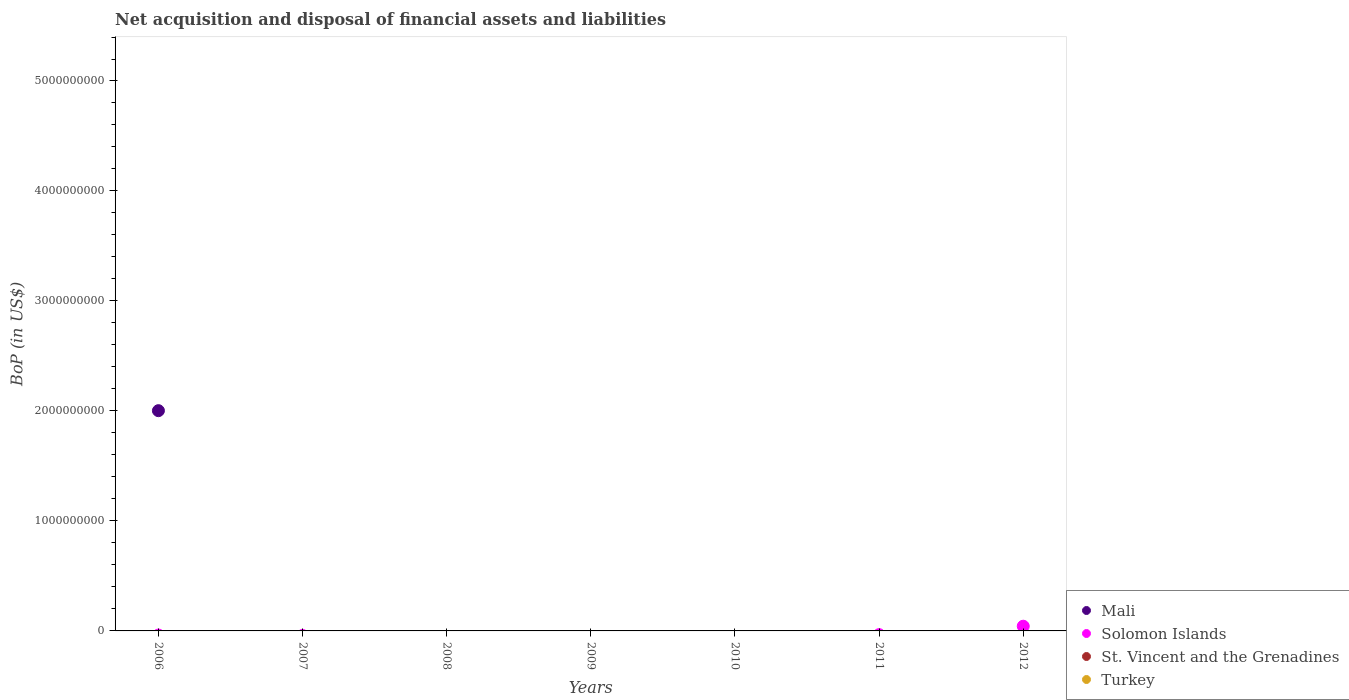Is the number of dotlines equal to the number of legend labels?
Offer a very short reply. No. What is the Balance of Payments in St. Vincent and the Grenadines in 2008?
Your answer should be compact. 0. Across all years, what is the maximum Balance of Payments in Mali?
Provide a short and direct response. 2.00e+09. In which year was the Balance of Payments in Mali maximum?
Ensure brevity in your answer.  2006. What is the total Balance of Payments in St. Vincent and the Grenadines in the graph?
Your answer should be very brief. 0. What is the average Balance of Payments in Mali per year?
Provide a succinct answer. 2.86e+08. In how many years, is the Balance of Payments in Solomon Islands greater than 1000000000 US$?
Your response must be concise. 0. What is the difference between the highest and the lowest Balance of Payments in Mali?
Your response must be concise. 2.00e+09. Does the Balance of Payments in Mali monotonically increase over the years?
Keep it short and to the point. No. Is the Balance of Payments in St. Vincent and the Grenadines strictly less than the Balance of Payments in Turkey over the years?
Give a very brief answer. No. How many dotlines are there?
Make the answer very short. 2. What is the difference between two consecutive major ticks on the Y-axis?
Keep it short and to the point. 1.00e+09. Does the graph contain any zero values?
Make the answer very short. Yes. How many legend labels are there?
Give a very brief answer. 4. What is the title of the graph?
Provide a short and direct response. Net acquisition and disposal of financial assets and liabilities. What is the label or title of the Y-axis?
Keep it short and to the point. BoP (in US$). What is the BoP (in US$) in Mali in 2006?
Ensure brevity in your answer.  2.00e+09. What is the BoP (in US$) in St. Vincent and the Grenadines in 2006?
Give a very brief answer. 0. What is the BoP (in US$) in Turkey in 2006?
Give a very brief answer. 0. What is the BoP (in US$) in Mali in 2007?
Keep it short and to the point. 0. What is the BoP (in US$) in Solomon Islands in 2007?
Your response must be concise. 0. What is the BoP (in US$) of St. Vincent and the Grenadines in 2007?
Ensure brevity in your answer.  0. What is the BoP (in US$) of Turkey in 2007?
Keep it short and to the point. 0. What is the BoP (in US$) in Mali in 2008?
Keep it short and to the point. 0. What is the BoP (in US$) of Solomon Islands in 2008?
Provide a succinct answer. 0. What is the BoP (in US$) of St. Vincent and the Grenadines in 2008?
Your answer should be compact. 0. What is the BoP (in US$) of Turkey in 2008?
Make the answer very short. 0. What is the BoP (in US$) of Mali in 2009?
Your response must be concise. 0. What is the BoP (in US$) in Solomon Islands in 2009?
Give a very brief answer. 0. What is the BoP (in US$) in St. Vincent and the Grenadines in 2009?
Offer a terse response. 0. What is the BoP (in US$) of Solomon Islands in 2010?
Give a very brief answer. 0. What is the BoP (in US$) in St. Vincent and the Grenadines in 2010?
Keep it short and to the point. 0. What is the BoP (in US$) in Turkey in 2010?
Give a very brief answer. 0. What is the BoP (in US$) in St. Vincent and the Grenadines in 2011?
Make the answer very short. 0. What is the BoP (in US$) in Turkey in 2011?
Offer a terse response. 0. What is the BoP (in US$) in Mali in 2012?
Provide a short and direct response. 0. What is the BoP (in US$) of Solomon Islands in 2012?
Your answer should be very brief. 4.28e+07. What is the BoP (in US$) of Turkey in 2012?
Your response must be concise. 0. Across all years, what is the maximum BoP (in US$) of Mali?
Offer a very short reply. 2.00e+09. Across all years, what is the maximum BoP (in US$) of Solomon Islands?
Offer a very short reply. 4.28e+07. What is the total BoP (in US$) of Mali in the graph?
Your answer should be very brief. 2.00e+09. What is the total BoP (in US$) of Solomon Islands in the graph?
Make the answer very short. 4.28e+07. What is the total BoP (in US$) of St. Vincent and the Grenadines in the graph?
Ensure brevity in your answer.  0. What is the total BoP (in US$) in Turkey in the graph?
Give a very brief answer. 0. What is the difference between the BoP (in US$) in Mali in 2006 and the BoP (in US$) in Solomon Islands in 2012?
Provide a short and direct response. 1.96e+09. What is the average BoP (in US$) in Mali per year?
Offer a very short reply. 2.86e+08. What is the average BoP (in US$) in Solomon Islands per year?
Offer a very short reply. 6.11e+06. What is the average BoP (in US$) of St. Vincent and the Grenadines per year?
Your answer should be compact. 0. What is the difference between the highest and the lowest BoP (in US$) of Mali?
Your answer should be very brief. 2.00e+09. What is the difference between the highest and the lowest BoP (in US$) of Solomon Islands?
Provide a succinct answer. 4.28e+07. 